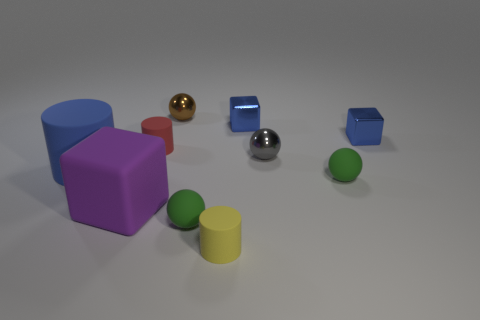Subtract all small shiny cubes. How many cubes are left? 1 Subtract 1 balls. How many balls are left? 3 Subtract all purple blocks. How many blocks are left? 2 Subtract all yellow cylinders. How many green balls are left? 2 Subtract all red rubber cylinders. Subtract all yellow matte cylinders. How many objects are left? 8 Add 6 tiny cylinders. How many tiny cylinders are left? 8 Add 9 small green metallic cylinders. How many small green metallic cylinders exist? 9 Subtract 0 red balls. How many objects are left? 10 Subtract all blocks. How many objects are left? 7 Subtract all red cylinders. Subtract all blue balls. How many cylinders are left? 2 